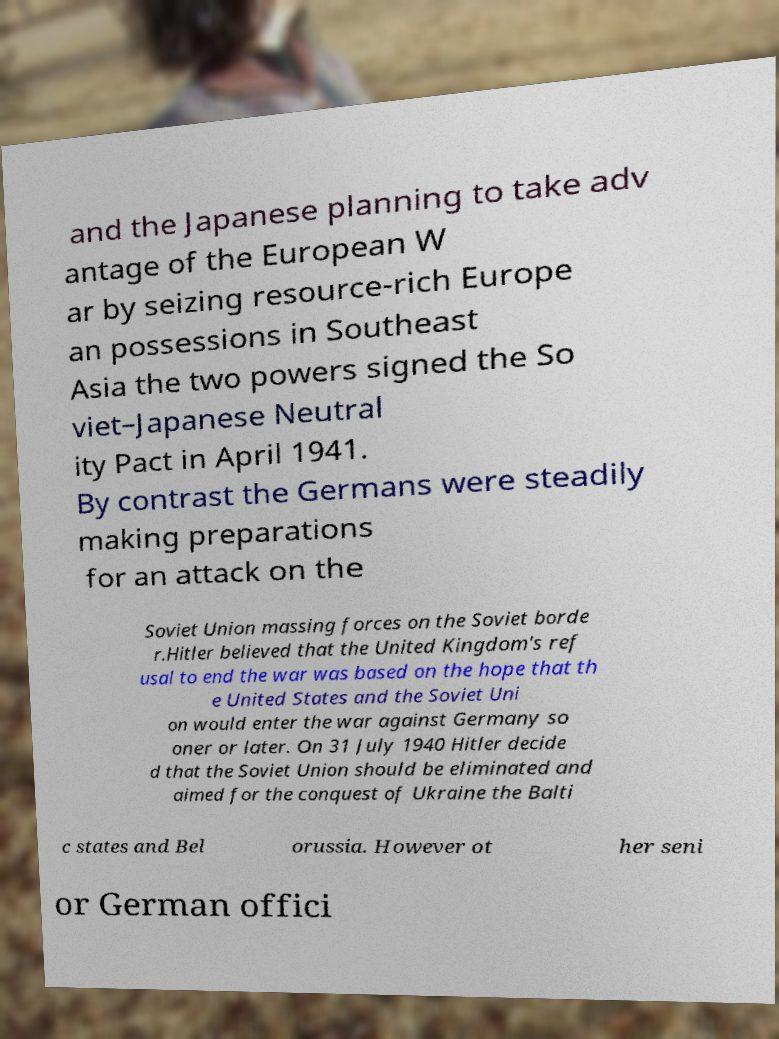Could you assist in decoding the text presented in this image and type it out clearly? and the Japanese planning to take adv antage of the European W ar by seizing resource-rich Europe an possessions in Southeast Asia the two powers signed the So viet–Japanese Neutral ity Pact in April 1941. By contrast the Germans were steadily making preparations for an attack on the Soviet Union massing forces on the Soviet borde r.Hitler believed that the United Kingdom's ref usal to end the war was based on the hope that th e United States and the Soviet Uni on would enter the war against Germany so oner or later. On 31 July 1940 Hitler decide d that the Soviet Union should be eliminated and aimed for the conquest of Ukraine the Balti c states and Bel orussia. However ot her seni or German offici 